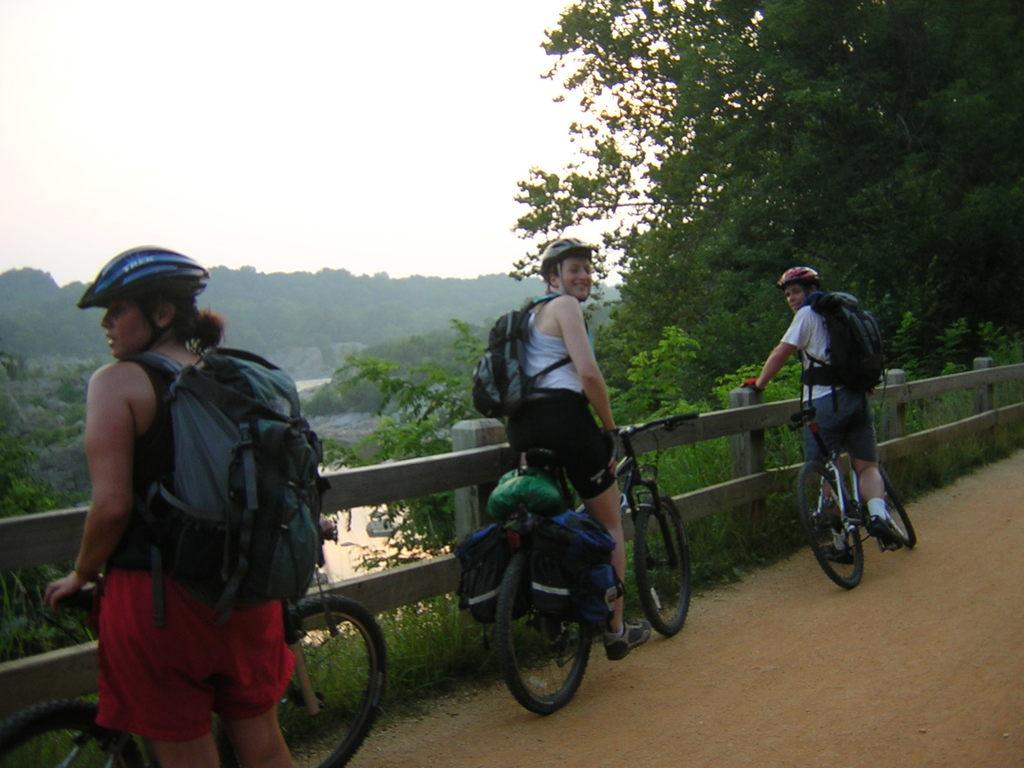How many people are present in the image? There are three people in the image. What are the people wearing? The people are wearing bags. What can be seen in the background of the image? There are trees and plants in the background of the image. What is located near the fence in the image? There are bicycles beside the fence. Is there any quicksand visible in the image? No, there is no quicksand present in the image. What type of street can be seen in the image? There is no street visible in the image. 